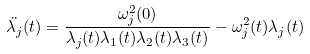<formula> <loc_0><loc_0><loc_500><loc_500>\ddot { \lambda _ { j } } ( t ) = \frac { \omega ^ { 2 } _ { j } ( 0 ) } { \lambda _ { j } ( t ) \lambda _ { 1 } ( t ) \lambda _ { 2 } ( t ) \lambda _ { 3 } ( t ) } - \omega _ { j } ^ { 2 } ( t ) \lambda _ { j } ( t )</formula> 